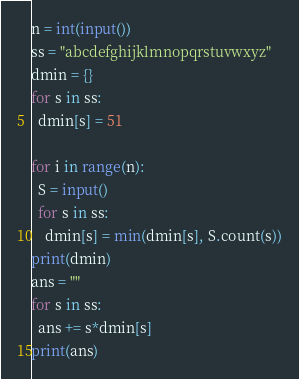<code> <loc_0><loc_0><loc_500><loc_500><_Python_>n = int(input())
ss = "abcdefghijklmnopqrstuvwxyz"
dmin = {}
for s in ss:
  dmin[s] = 51

for i in range(n):
  S = input()
  for s in ss:
    dmin[s] = min(dmin[s], S.count(s))
print(dmin)
ans = ""
for s in ss:
  ans += s*dmin[s]
print(ans)</code> 